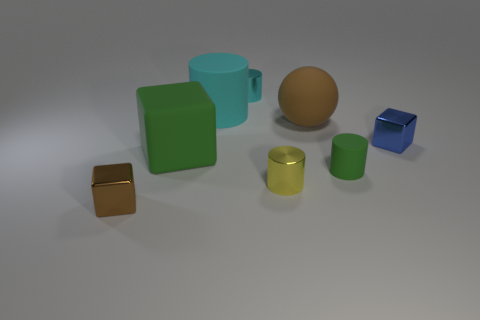Is there anything else that is the same material as the tiny cyan object?
Your answer should be compact. Yes. How many objects are both in front of the big green matte block and right of the big cube?
Your answer should be very brief. 2. There is a tiny metal cube to the left of the matte cylinder in front of the large brown object; what color is it?
Your response must be concise. Brown. Is the number of small metallic objects to the left of the green block the same as the number of small gray rubber cubes?
Keep it short and to the point. No. What number of metallic cylinders are in front of the cyan object that is in front of the metal cylinder that is behind the blue object?
Offer a very short reply. 1. There is a tiny cube left of the big brown thing; what is its color?
Provide a succinct answer. Brown. There is a large object that is on the left side of the large matte sphere and behind the large green thing; what is its material?
Provide a short and direct response. Rubber. How many large brown spheres are in front of the green object that is to the left of the cyan metal object?
Your response must be concise. 0. What shape is the brown metallic object?
Your answer should be very brief. Cube. What is the shape of the large brown object that is made of the same material as the green cube?
Make the answer very short. Sphere. 